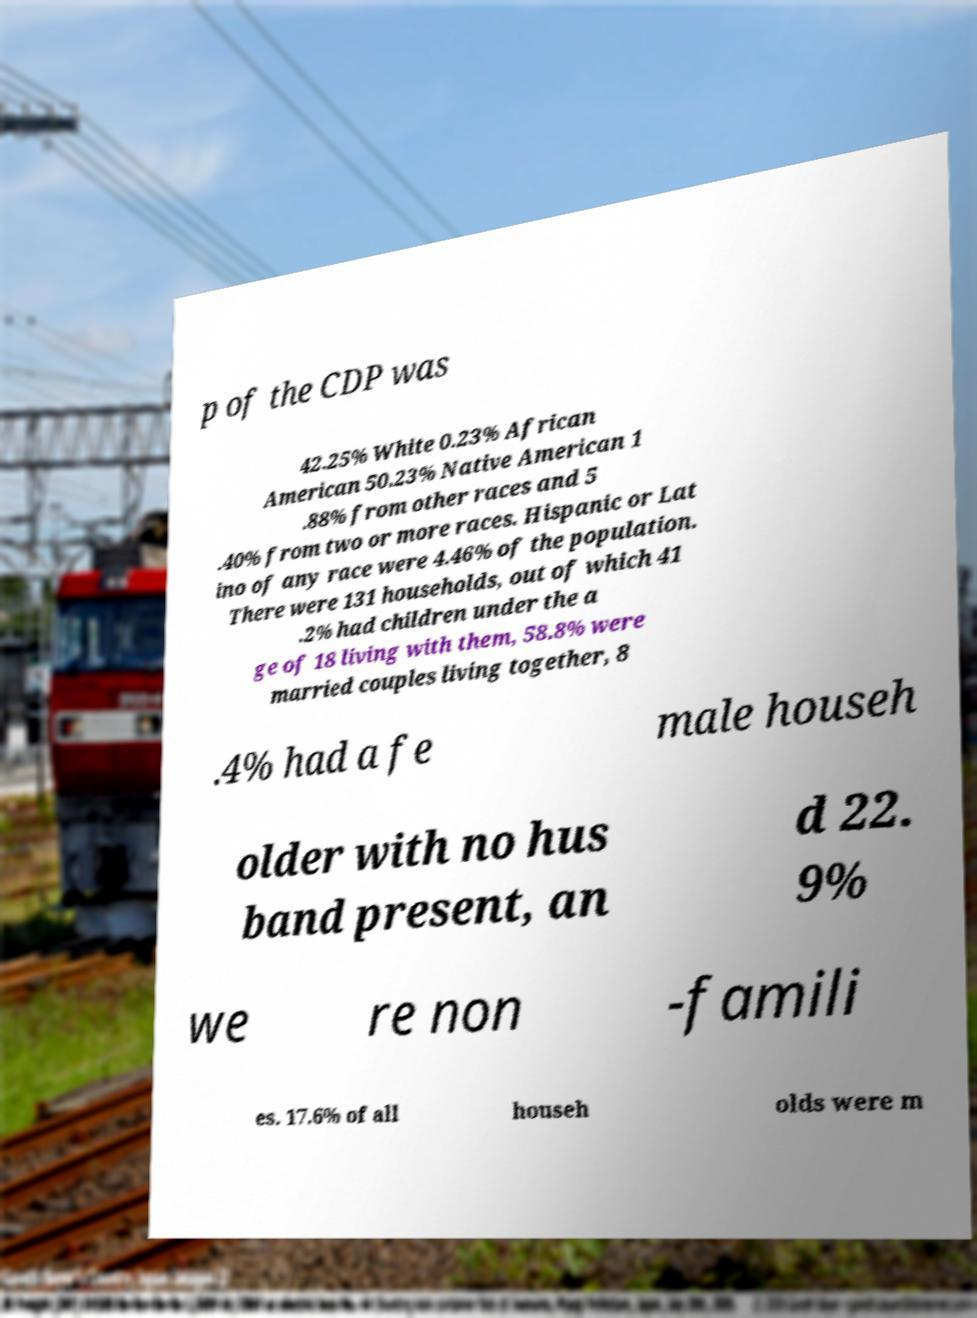For documentation purposes, I need the text within this image transcribed. Could you provide that? p of the CDP was 42.25% White 0.23% African American 50.23% Native American 1 .88% from other races and 5 .40% from two or more races. Hispanic or Lat ino of any race were 4.46% of the population. There were 131 households, out of which 41 .2% had children under the a ge of 18 living with them, 58.8% were married couples living together, 8 .4% had a fe male househ older with no hus band present, an d 22. 9% we re non -famili es. 17.6% of all househ olds were m 